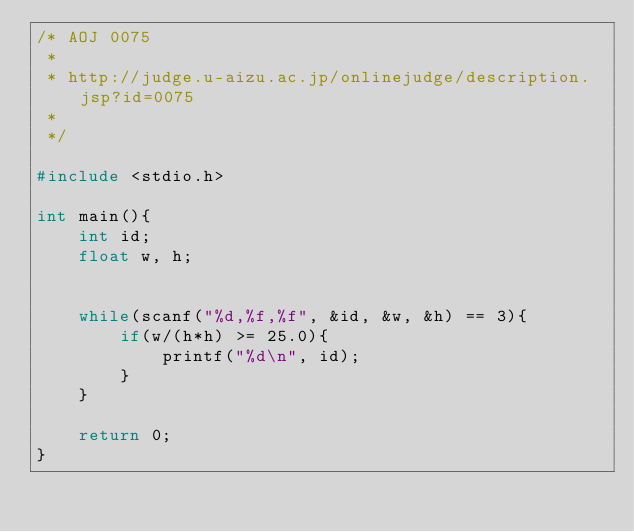Convert code to text. <code><loc_0><loc_0><loc_500><loc_500><_C_>/* AOJ 0075
 *
 * http://judge.u-aizu.ac.jp/onlinejudge/description.jsp?id=0075
 *
 */

#include <stdio.h>

int main(){
    int id;
    float w, h;


    while(scanf("%d,%f,%f", &id, &w, &h) == 3){
        if(w/(h*h) >= 25.0){
            printf("%d\n", id);
        }
    }

    return 0;
}</code> 